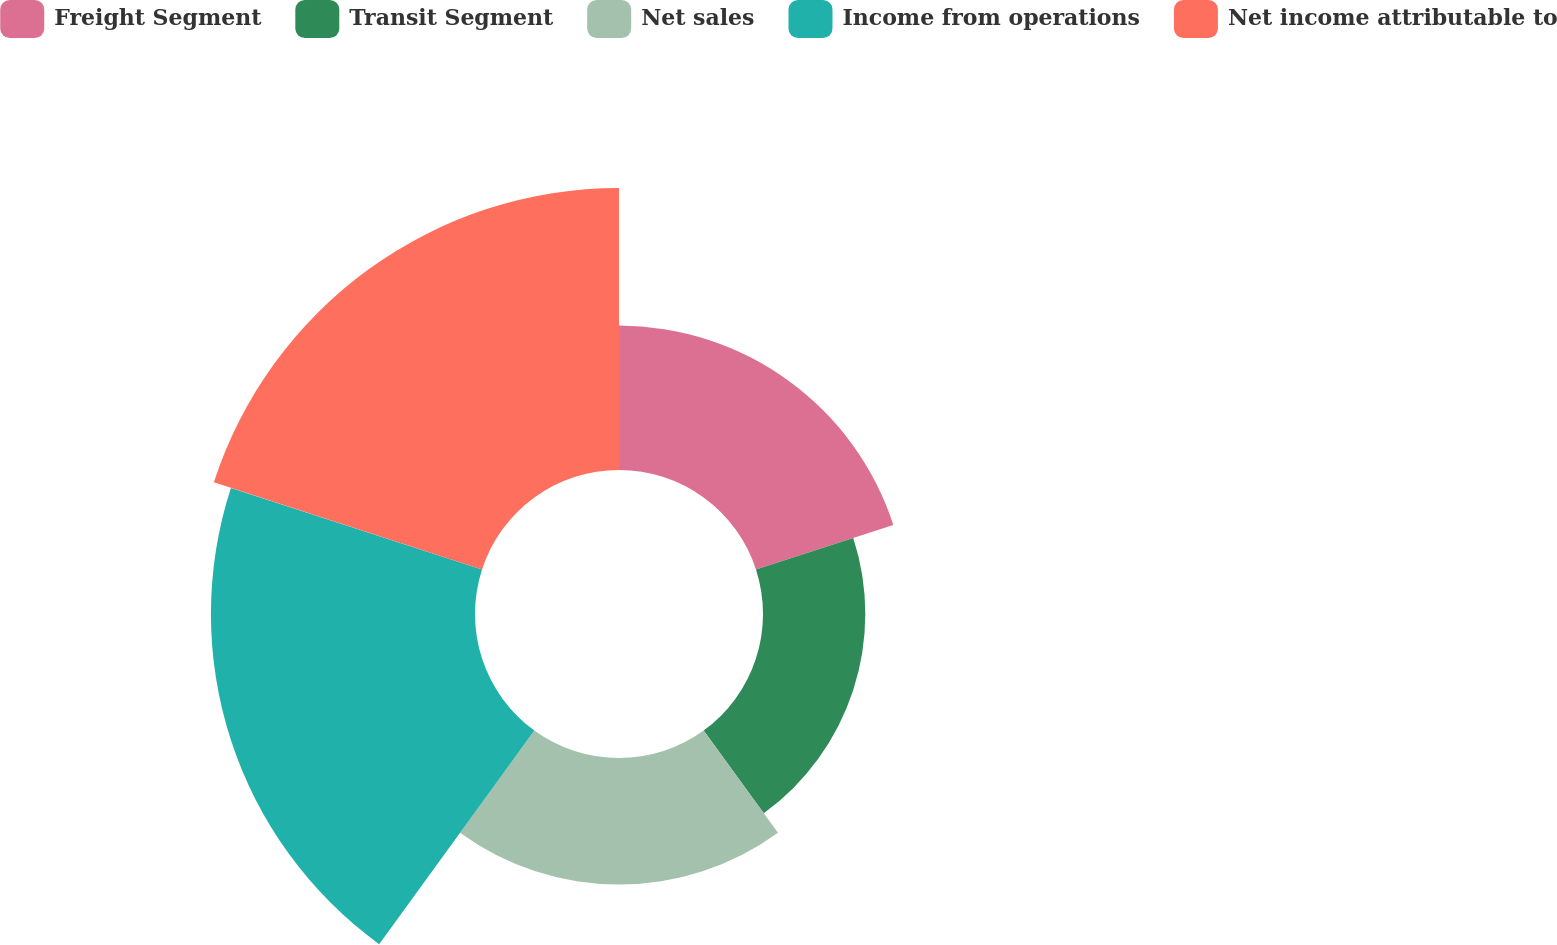Convert chart. <chart><loc_0><loc_0><loc_500><loc_500><pie_chart><fcel>Freight Segment<fcel>Transit Segment<fcel>Net sales<fcel>Income from operations<fcel>Net income attributable to<nl><fcel>15.71%<fcel>11.13%<fcel>13.76%<fcel>28.73%<fcel>30.68%<nl></chart> 